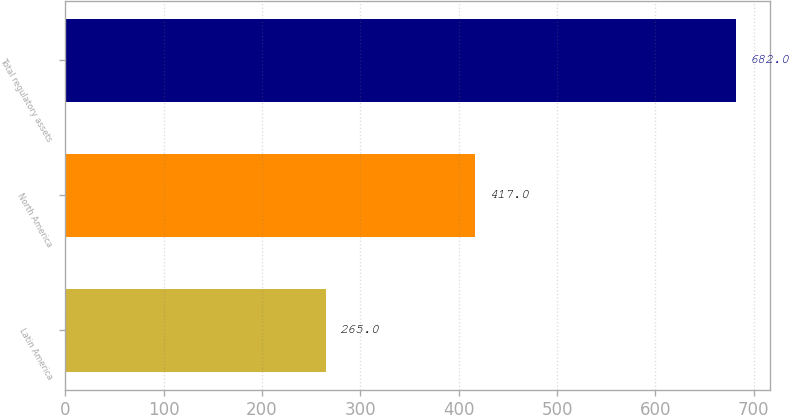<chart> <loc_0><loc_0><loc_500><loc_500><bar_chart><fcel>Latin America<fcel>North America<fcel>Total regulatory assets<nl><fcel>265<fcel>417<fcel>682<nl></chart> 